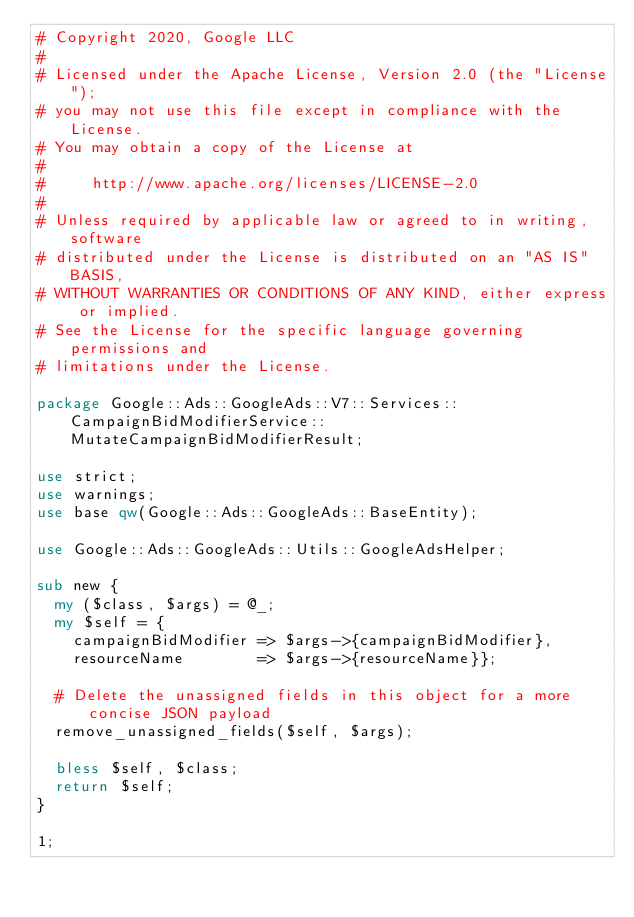Convert code to text. <code><loc_0><loc_0><loc_500><loc_500><_Perl_># Copyright 2020, Google LLC
#
# Licensed under the Apache License, Version 2.0 (the "License");
# you may not use this file except in compliance with the License.
# You may obtain a copy of the License at
#
#     http://www.apache.org/licenses/LICENSE-2.0
#
# Unless required by applicable law or agreed to in writing, software
# distributed under the License is distributed on an "AS IS" BASIS,
# WITHOUT WARRANTIES OR CONDITIONS OF ANY KIND, either express or implied.
# See the License for the specific language governing permissions and
# limitations under the License.

package Google::Ads::GoogleAds::V7::Services::CampaignBidModifierService::MutateCampaignBidModifierResult;

use strict;
use warnings;
use base qw(Google::Ads::GoogleAds::BaseEntity);

use Google::Ads::GoogleAds::Utils::GoogleAdsHelper;

sub new {
  my ($class, $args) = @_;
  my $self = {
    campaignBidModifier => $args->{campaignBidModifier},
    resourceName        => $args->{resourceName}};

  # Delete the unassigned fields in this object for a more concise JSON payload
  remove_unassigned_fields($self, $args);

  bless $self, $class;
  return $self;
}

1;
</code> 